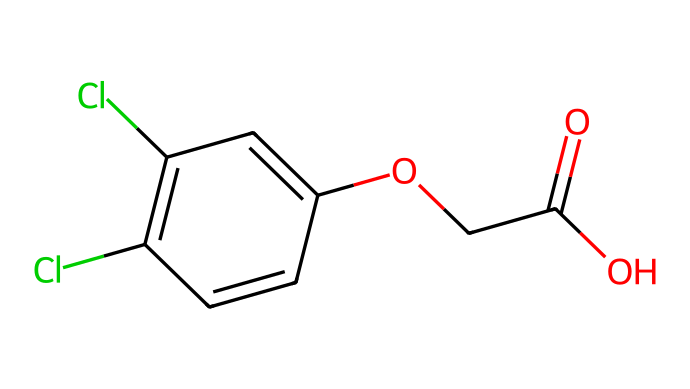How many chlorine atoms are present? The SMILES representation includes "Cl" which indicates the presence of chlorine atoms. Counting the occurrences, we find that there are two "Cl" present.
Answer: two What is the molecular formula of 2,4-D? By analyzing the SMILES, we can derive that the molecular formula is C8H6Cl2O3. The carbon (C), hydrogen (H), chlorine (Cl), and oxygen (O) counts can be tallied based on the structure.
Answer: C8H6Cl2O3 How many carbon atoms does 2,4-D have? The structure shows a total of eight carbon atoms, represented by the number of carbons in the chain and the aromatic ring.
Answer: eight Does this herbicide contain an ester functional group? Yes, the presence of the "OCC(=O)" indicates an ester functional group, which is characterized by the -O- connection to a carbonyl (C=O) group.
Answer: yes What type of herbicide is 2,4-D classified as? 2,4-D is classified as a synthetic herbicide, specifically a broadleaf herbicide, because its molecular structure is designed to target specific plant growth processes.
Answer: synthetic herbicide Is 2,4-D selective for certain plants? Yes, 2,4-D is selective, designed to kill broadleaf plants while leaving grasses unharmed, due to its hormonal action on plant growth regulators.
Answer: yes What is one main application of 2,4-D in agriculture? One main application of 2,4-D is in controlling weeds in crops, especially in cereal crops like wheat, where it helps manage unwanted broadleaf plants.
Answer: weed control 